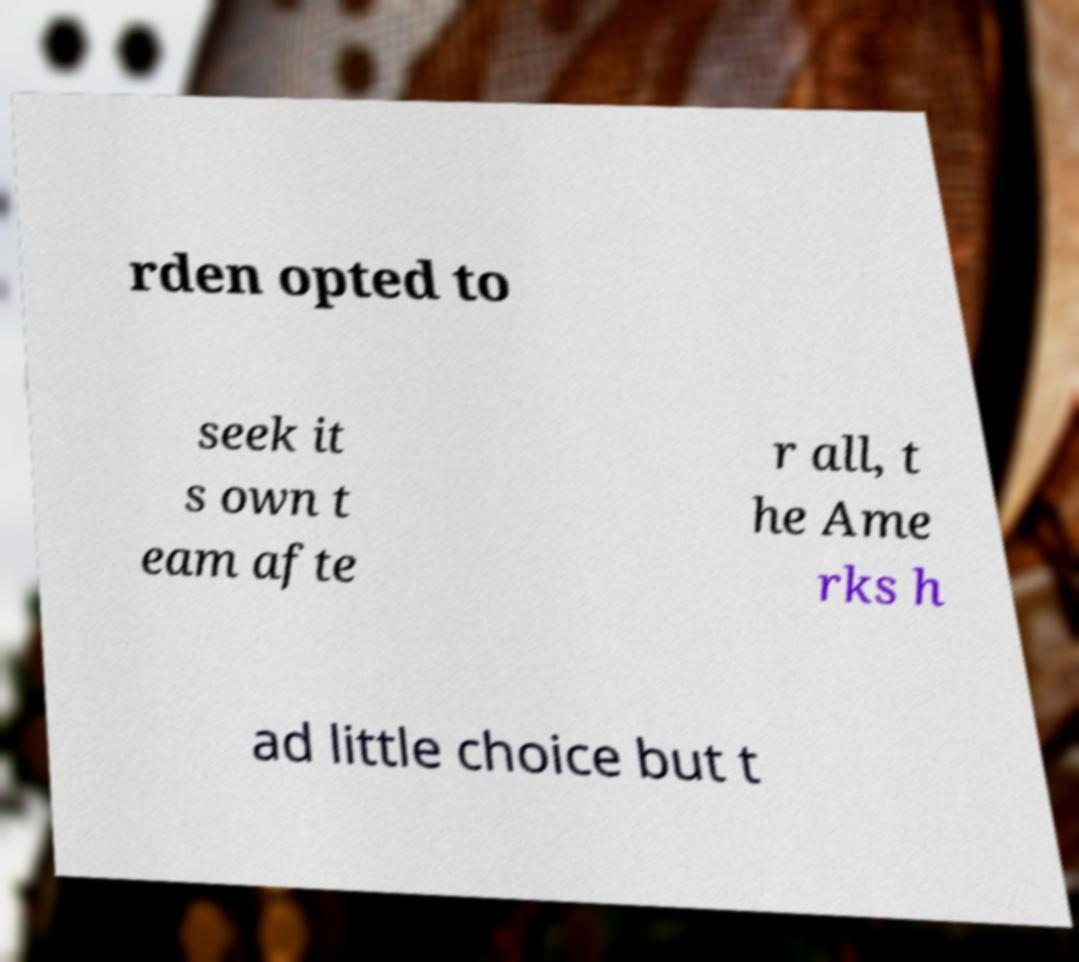Could you assist in decoding the text presented in this image and type it out clearly? rden opted to seek it s own t eam afte r all, t he Ame rks h ad little choice but t 